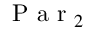Convert formula to latex. <formula><loc_0><loc_0><loc_500><loc_500>P a r _ { 2 }</formula> 